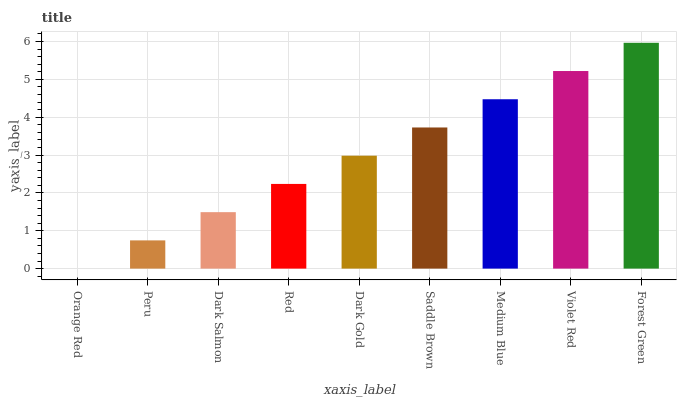Is Orange Red the minimum?
Answer yes or no. Yes. Is Forest Green the maximum?
Answer yes or no. Yes. Is Peru the minimum?
Answer yes or no. No. Is Peru the maximum?
Answer yes or no. No. Is Peru greater than Orange Red?
Answer yes or no. Yes. Is Orange Red less than Peru?
Answer yes or no. Yes. Is Orange Red greater than Peru?
Answer yes or no. No. Is Peru less than Orange Red?
Answer yes or no. No. Is Dark Gold the high median?
Answer yes or no. Yes. Is Dark Gold the low median?
Answer yes or no. Yes. Is Violet Red the high median?
Answer yes or no. No. Is Orange Red the low median?
Answer yes or no. No. 